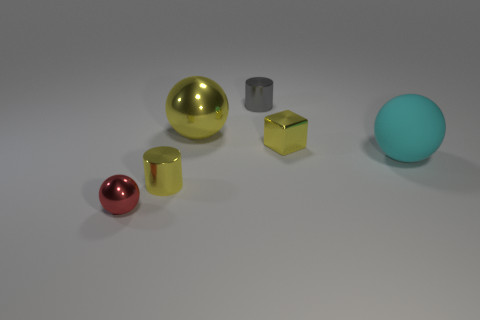Add 3 yellow metal cubes. How many objects exist? 9 Subtract all cubes. How many objects are left? 5 Subtract 0 brown cubes. How many objects are left? 6 Subtract all yellow blocks. Subtract all red metal balls. How many objects are left? 4 Add 5 cyan matte balls. How many cyan matte balls are left? 6 Add 1 rubber objects. How many rubber objects exist? 2 